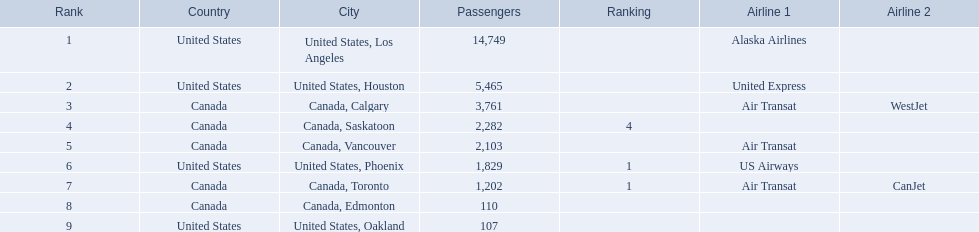Which cities had less than 2,000 passengers? United States, Phoenix, Canada, Toronto, Canada, Edmonton, United States, Oakland. Of these cities, which had fewer than 1,000 passengers? Canada, Edmonton, United States, Oakland. Of the cities in the previous answer, which one had only 107 passengers? United States, Oakland. What numbers are in the passengers column? 14,749, 5,465, 3,761, 2,282, 2,103, 1,829, 1,202, 110, 107. Which number is the lowest number in the passengers column? 107. What city is associated with this number? United States, Oakland. 